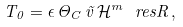Convert formula to latex. <formula><loc_0><loc_0><loc_500><loc_500>T _ { 0 } = \epsilon \, \Theta _ { C } \, \vec { v } \, \mathcal { H } ^ { m } \ r e s R \, ,</formula> 